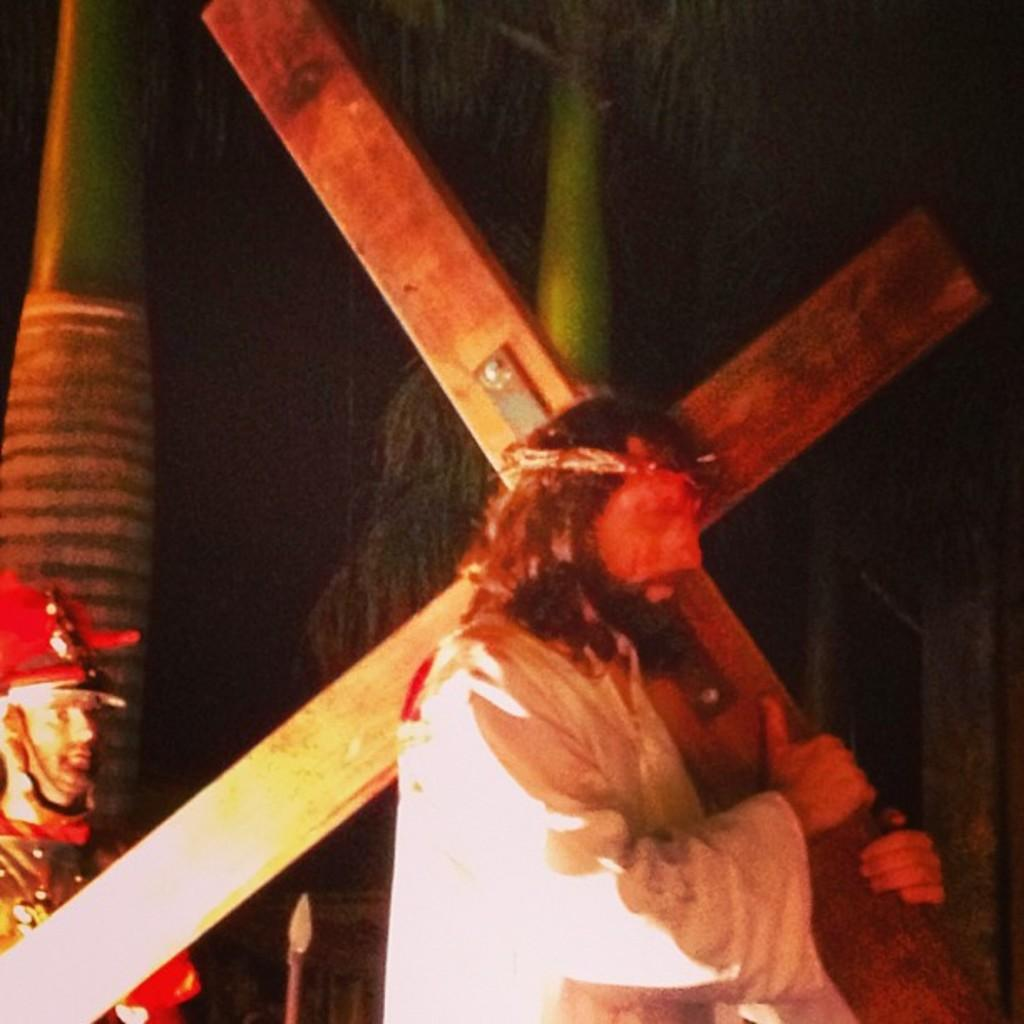What is the man in the image holding? The man is holding a cross in the image. What is the other man in the image wearing? The other man is wearing a soldier costume in the image. What can be seen in the background of the image? There are two tree branches visible in the background of the image. How would you describe the lighting in the image? The background appears to be dark in the image. What type of friction can be observed between the tree branches in the image? There is no friction between the tree branches in the image, as they are not interacting with each other. Is there a connection between the man holding the cross and the man in the soldier costume? While it is not explicitly stated, the presence of both men in the same image might suggest a connection or relationship between them. However, the nature of this connection cannot be determined from the image alone. 